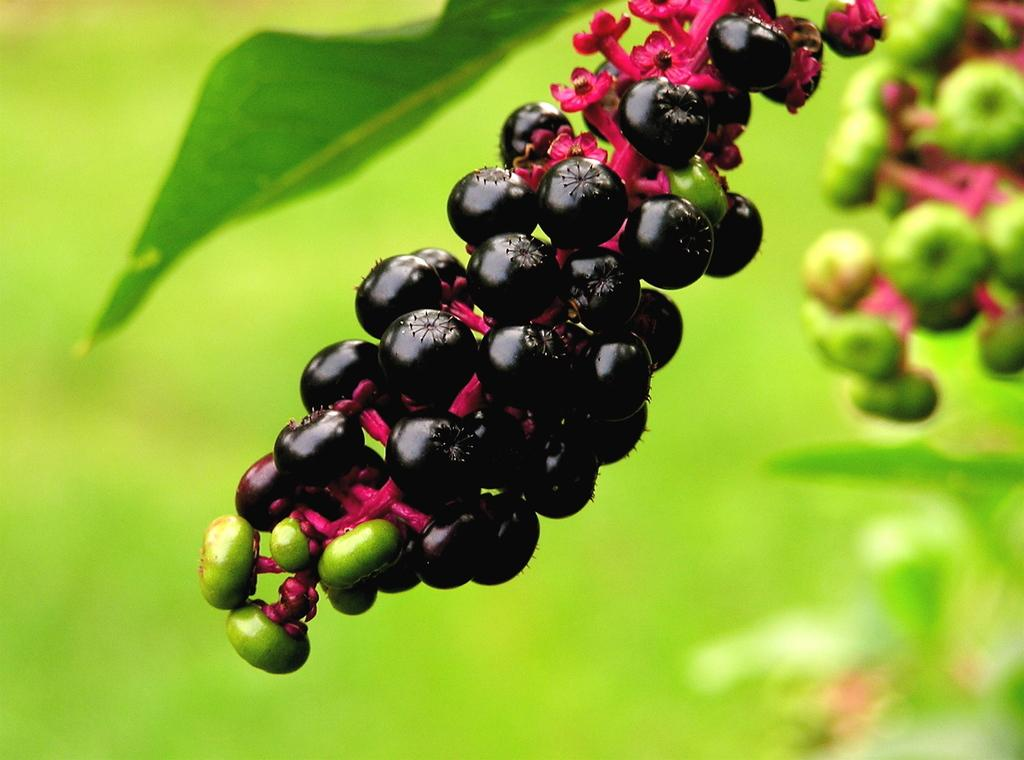What types of food can be seen in the foreground of the image? There are fruits in the foreground of the image. What can be seen in the background of the image? There is a plant in the background of the image. How many kittens are playing with the rake in the image? There are no kittens or rakes present in the image. What type of train can be seen passing by in the image? There is no train visible in the image. 